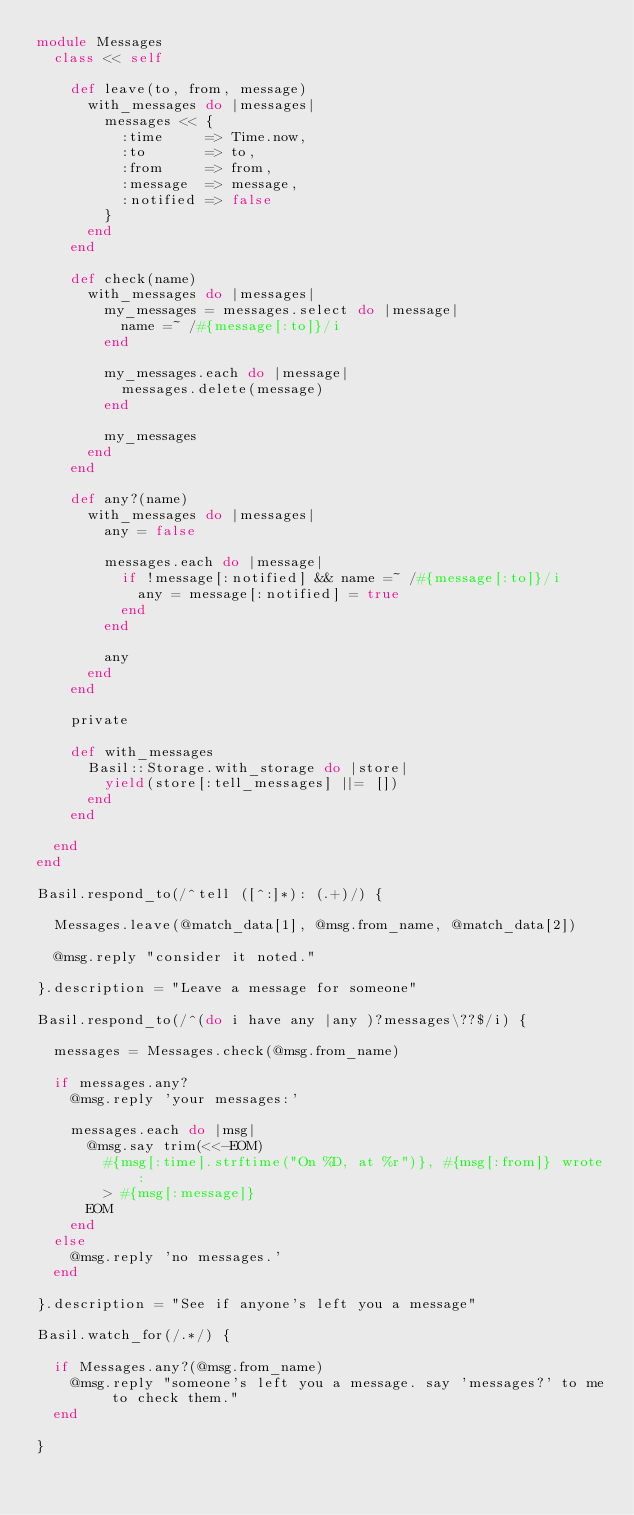<code> <loc_0><loc_0><loc_500><loc_500><_Ruby_>module Messages
  class << self

    def leave(to, from, message)
      with_messages do |messages|
        messages << {
          :time     => Time.now,
          :to       => to,
          :from     => from,
          :message  => message,
          :notified => false
        }
      end
    end

    def check(name)
      with_messages do |messages|
        my_messages = messages.select do |message|
          name =~ /#{message[:to]}/i
        end

        my_messages.each do |message|
          messages.delete(message)
        end

        my_messages
      end
    end

    def any?(name)
      with_messages do |messages|
        any = false

        messages.each do |message|
          if !message[:notified] && name =~ /#{message[:to]}/i
            any = message[:notified] = true
          end
        end

        any
      end
    end

    private

    def with_messages
      Basil::Storage.with_storage do |store|
        yield(store[:tell_messages] ||= [])
      end
    end

  end
end

Basil.respond_to(/^tell ([^:]*): (.+)/) {

  Messages.leave(@match_data[1], @msg.from_name, @match_data[2])

  @msg.reply "consider it noted."

}.description = "Leave a message for someone"

Basil.respond_to(/^(do i have any |any )?messages\??$/i) {

  messages = Messages.check(@msg.from_name)

  if messages.any?
    @msg.reply 'your messages:'

    messages.each do |msg|
      @msg.say trim(<<-EOM)
        #{msg[:time].strftime("On %D, at %r")}, #{msg[:from]} wrote:
        > #{msg[:message]}
      EOM
    end
  else
    @msg.reply 'no messages.'
  end

}.description = "See if anyone's left you a message"

Basil.watch_for(/.*/) {

  if Messages.any?(@msg.from_name)
    @msg.reply "someone's left you a message. say 'messages?' to me to check them."
  end

}
</code> 